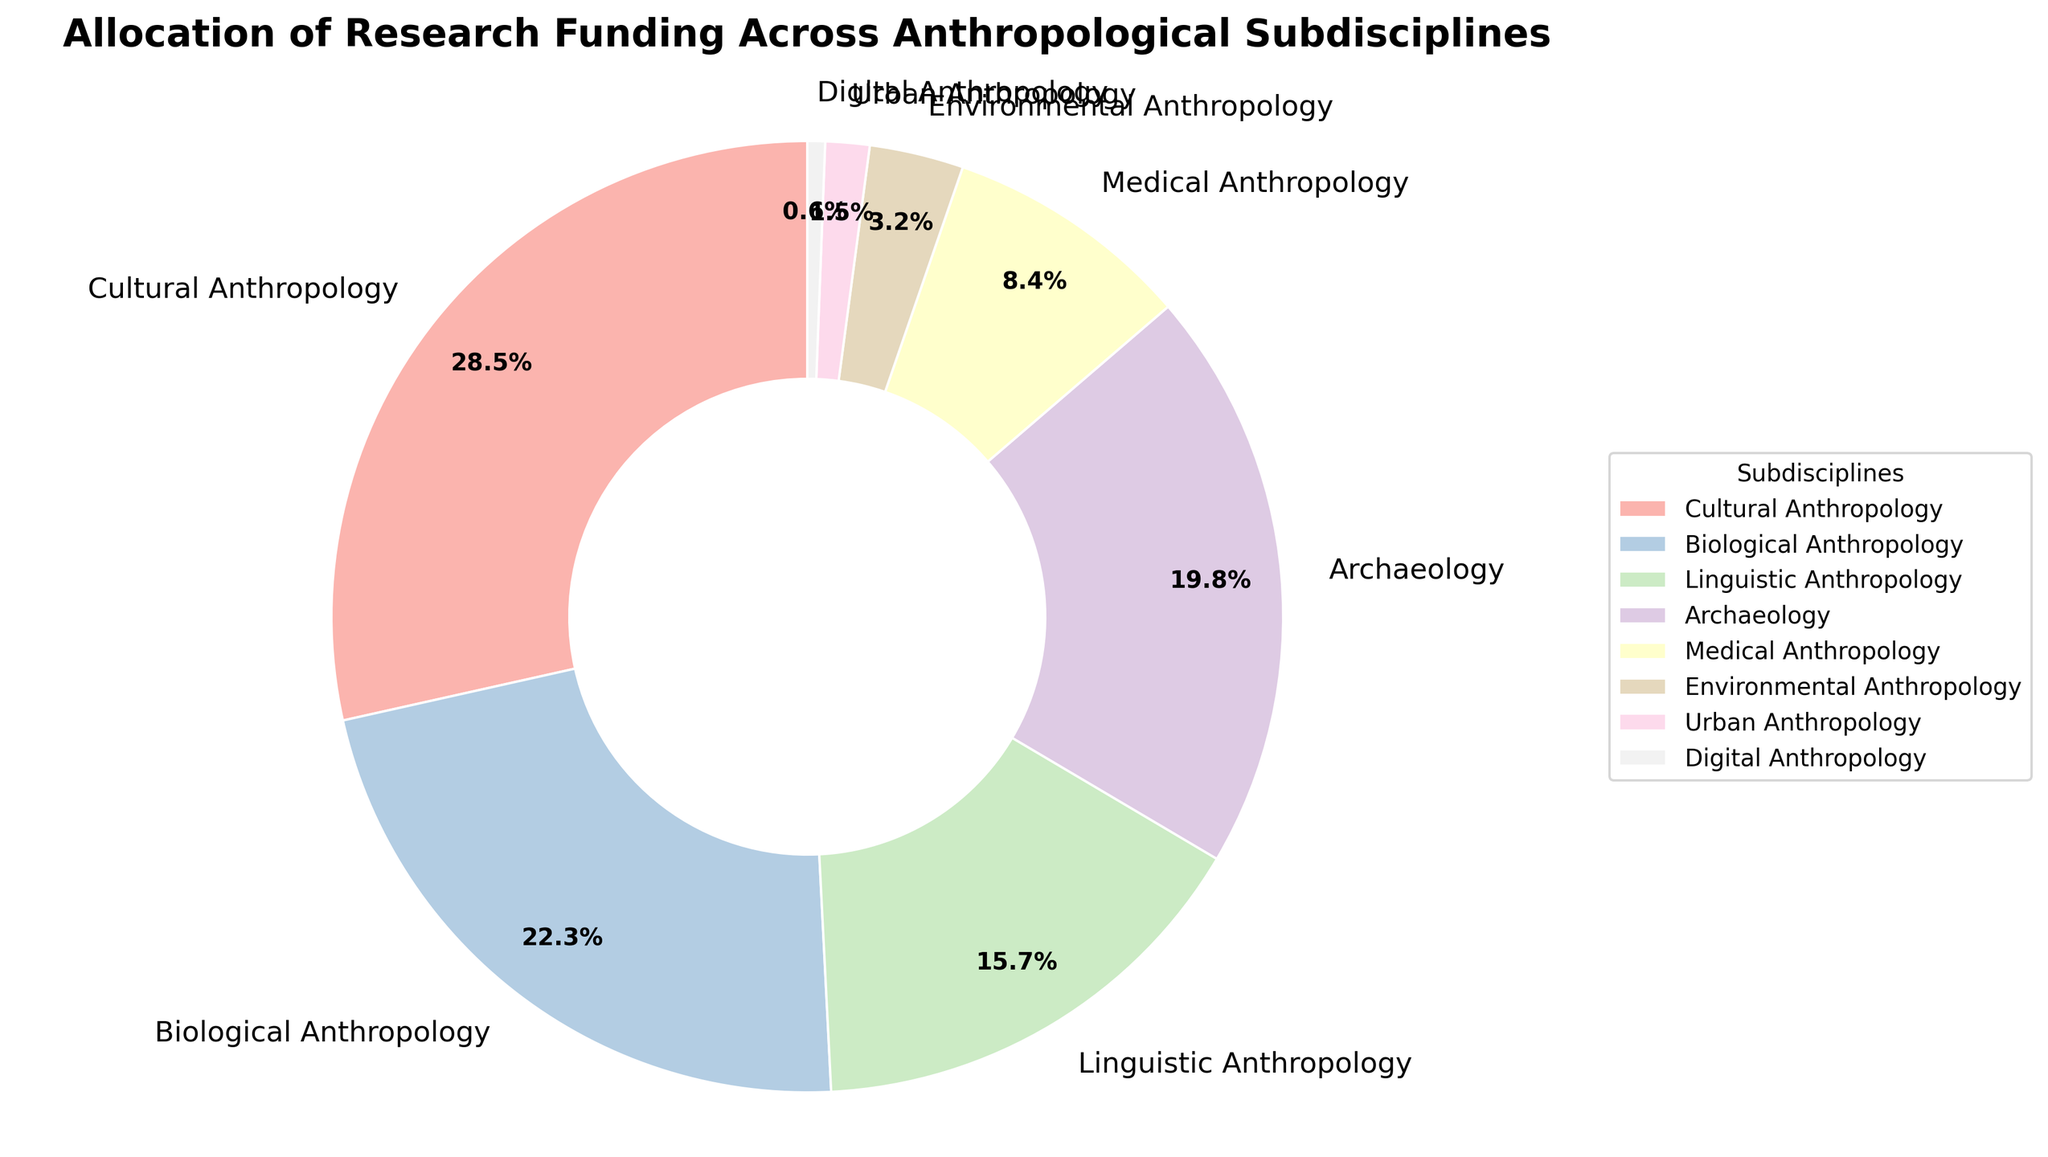What is the most funded subdiscipline? The figure shows that Cultural Anthropology has the largest slice of the pie.
Answer: Cultural Anthropology Which subdiscipline received the least amount of funding? The smallest slice of the pie represents Digital Anthropology.
Answer: Digital Anthropology How much more funding does Cultural Anthropology receive compared to Medical Anthropology? Cultural Anthropology has 28.5%, and Medical Anthropology has 8.4%. Subtract Medical Anthropology's funding from Cultural Anthropology's funding: 28.5 - 8.4 = 20.1
Answer: 20.1% Which two subdisciplines have the closest funding percentages? By comparing the slices, Linguistic Anthropology (15.7%) and Archaeology (19.8%) are the closest. The difference is 19.8 - 15.7 = 4.1
Answer: Linguistic Anthropology and Archaeology What percentage of the total funding is allocated to Environmental Anthropology and Urban Anthropology combined? Sum the percentages of Environmental Anthropology (3.2%) and Urban Anthropology (1.5%): 3.2 + 1.5 = 4.7
Answer: 4.7% Which subdisciplines together account for less than 10% of the funding? Urban Anthropology (1.5%) and Digital Anthropology (0.6%) combined is 1.5 + 0.6 = 2.1. Adding Environmental Anthropology (3.2%), the total is 2.1 + 3.2 = 5.3. Adding Medical Anthropology (8.4%) would exceed 10%.
Answer: Urban Anthropology, Digital Anthropology, Environmental Anthropology What is the difference in funding allocation between Biological Anthropology and Archaeology? Biological Anthropology is 22.3% and Archaeology is 19.8%. The difference is 22.3 - 19.8 = 2.5
Answer: 2.5% How does the funding for Medical Anthropology compare to that of Linguistic Anthropology? Medical Anthropology has 8.4%, while Linguistic Anthropology has 15.7%. Medical Anthropology's funding is less.
Answer: Less Which subdisciplines together make up more than 50% of the funding? Start adding the highest percentages: Cultural Anthropology (28.5%), Biological Anthropology (22.3%) combined is 28.5 + 22.3 = 50.8.
Answer: Cultural Anthropology and Biological Anthropology 